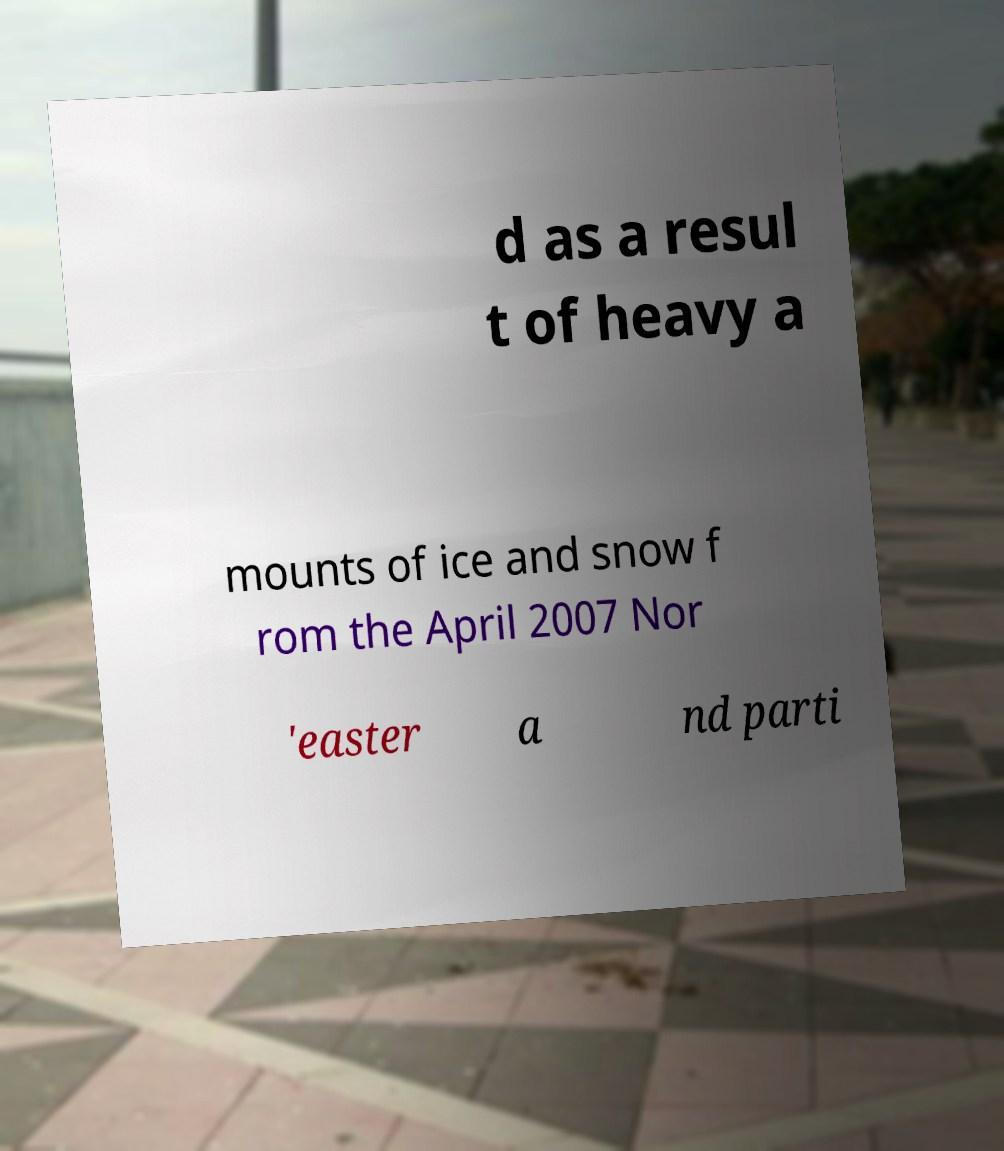What messages or text are displayed in this image? I need them in a readable, typed format. d as a resul t of heavy a mounts of ice and snow f rom the April 2007 Nor 'easter a nd parti 